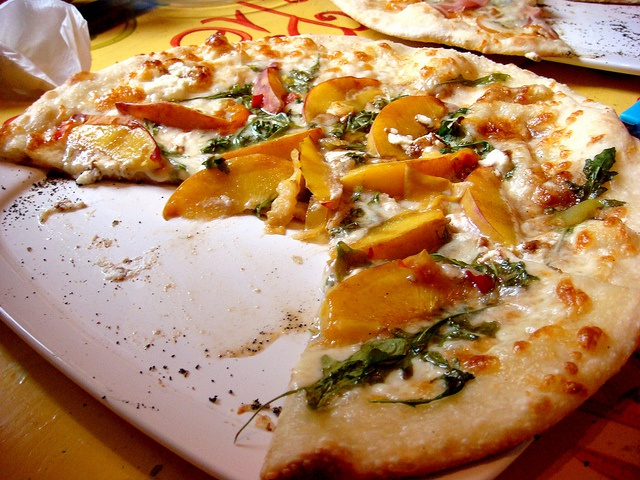Describe the objects in this image and their specific colors. I can see pizza in maroon, red, tan, and ivory tones, dining table in maroon and brown tones, apple in maroon, red, and orange tones, pizza in maroon, beige, and tan tones, and apple in maroon, white, tan, and red tones in this image. 